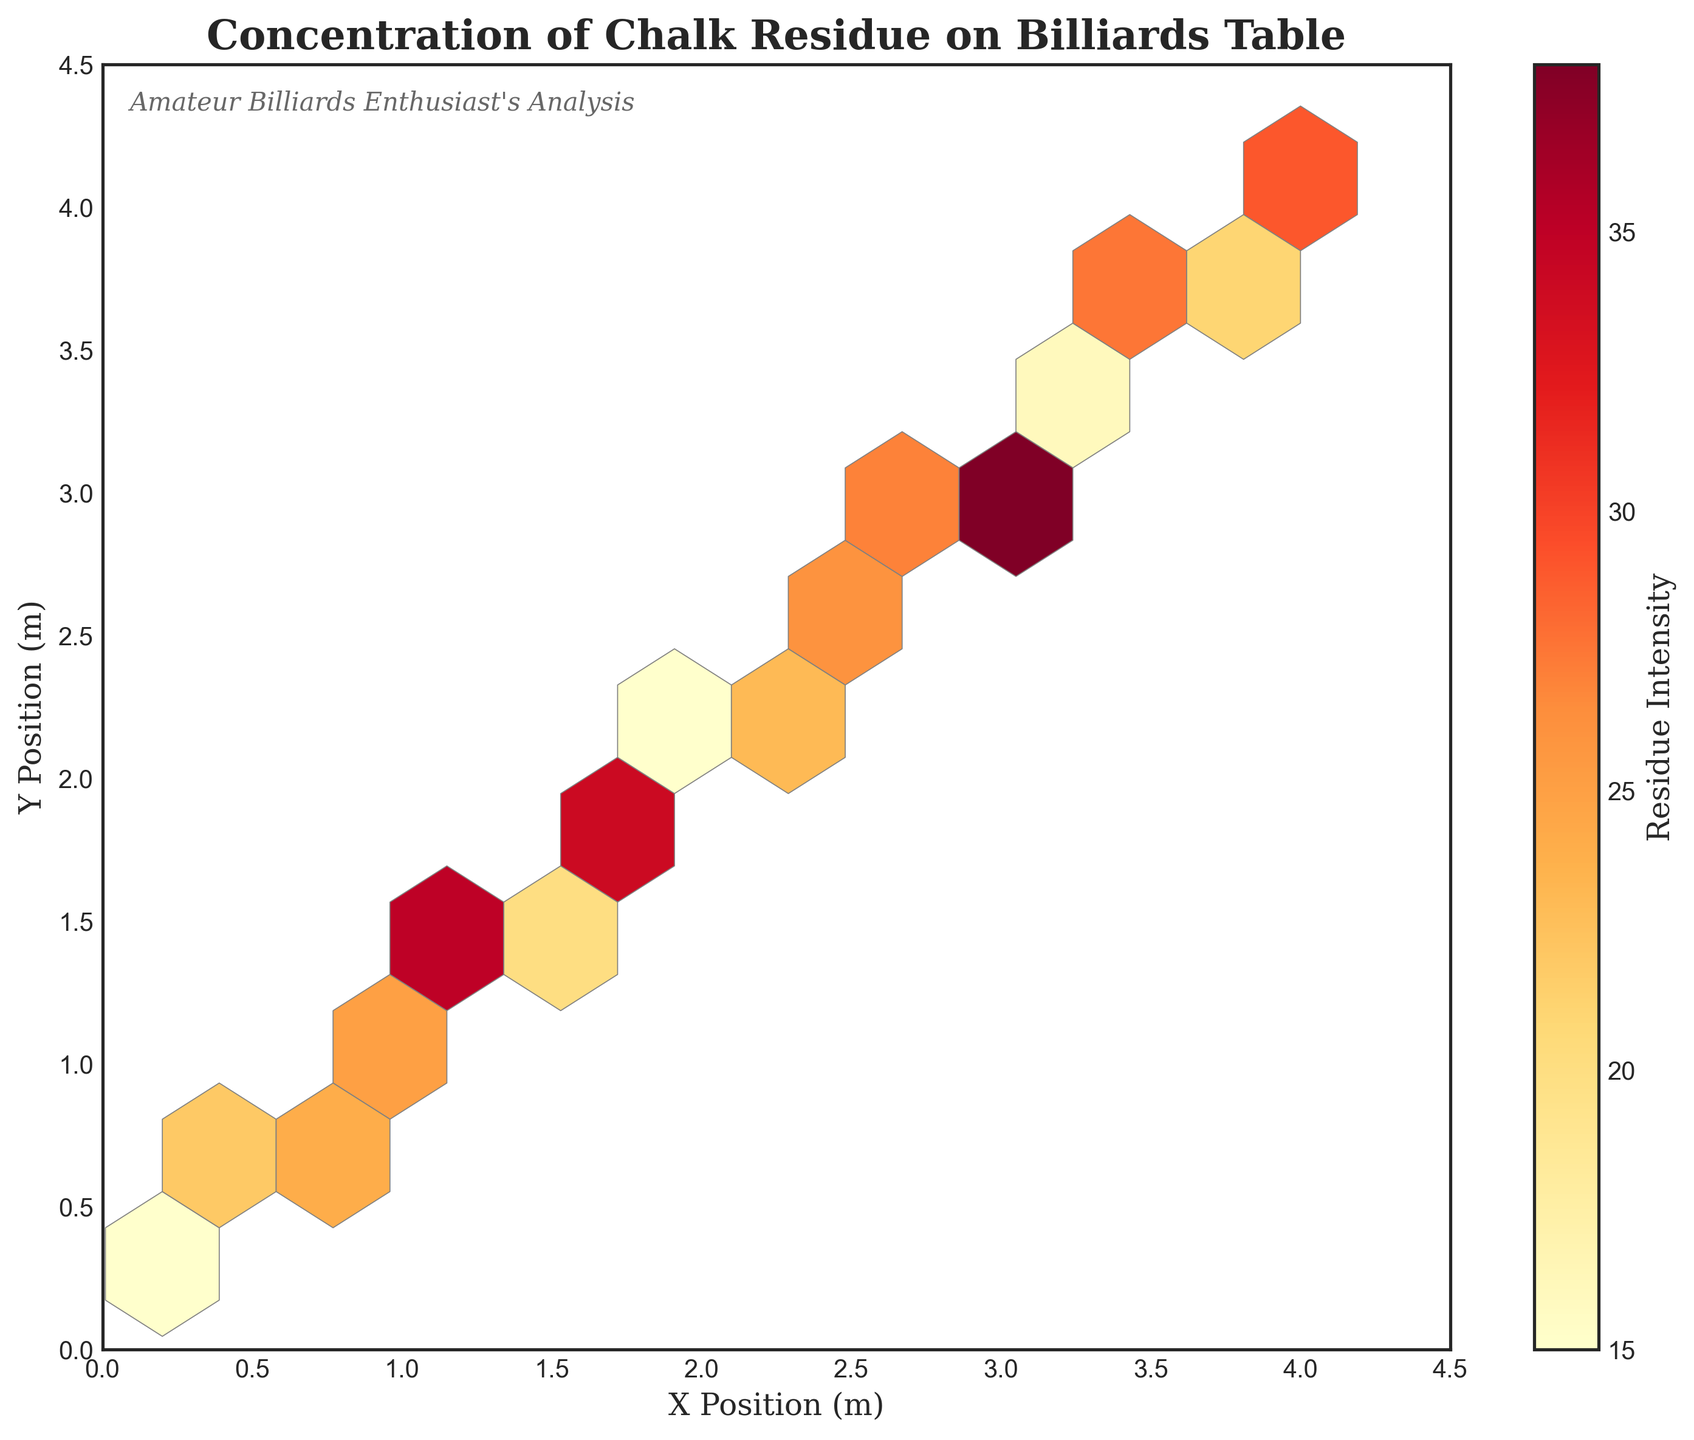What is the title of the figure? The title is located at the top of the plot and is designed to summarize the main idea of the visualization. It helps viewers quickly understand the subject of the plot.
Answer: Concentration of Chalk Residue on Billiards Table What is the color indicating the highest residue intensity on the plot? The color representing the highest residue intensity can be identified from the colorbar on the right side of the figure. The lightest color in the 'YlOrRd' (Yellow-Orange-Red) colormap indicates the highest intensity.
Answer: Light Yellow What does the color bar on the right of the plot represent? The color bar is a key that indicates how the different colors in the hexbin plot correspond to different residue intensity values. It provides a range of intensity values associated with the example colors.
Answer: Residue Intensity What are the ranges of the x and y-axes? The ranges of the x and y-axes can be determined by looking at the minimum and maximum values marked on each axis. These values are set to encompass the data points plotted on the figure.
Answer: 0 to 4.5 meters Which hexagon shape displays the highest concentration of residue and what is its approximate x and y position? By examining the hexagons and comparing their color intensities using the color bar, we can identify the hexagon with the highest concentration. This hexagon will be the lightest in color according to the 'YlOrRd' colormap. The position can be approximated by locating this hexagon on the plot.
Answer: Around x = 1.8 and y = 1.9 meters How does the residue intensity compare between the top left and bottom right corners of the plot? To answer this, observe the colors of hexagons at both corners and compare their intensities using the color bar. Darker colors indicate lower residues while lighter colors indicate higher residues.
Answer: Higher in the bottom right corner Does the plot suggest any specific area on the billiards table where residue tends to accumulate more? Look for clusters of hexagons that have lighter shades indicating higher concentrations. Multiple hexagons clustered together with high intensities can suggest an area with more residue.
Answer: Yes, around the central region near x = 1.8 and y = 1.9 meters What may be inferred about residue intensity patterns along the diagonal from the bottom-left to the top-right corner of the plot? Trace the diagonal and observe the changes in color. Follow the color transitions and compare them against the color bar to note the variations in residue intensity.
Answer: Varies, generally increasing toward the middle What is the general trend of residue intensity as you move from left to right on the plot? By visually inspecting the color change from the left to the right across the plot, we can generalize how the residue intensity shifts horizontally using the color bar for reference.
Answer: Generally increasing How many data points appear to have an intensity equal to 15? This requires identifying hexagons that correspond to an intensity of 15 using the color bar and counting these hexagons.
Answer: Two 